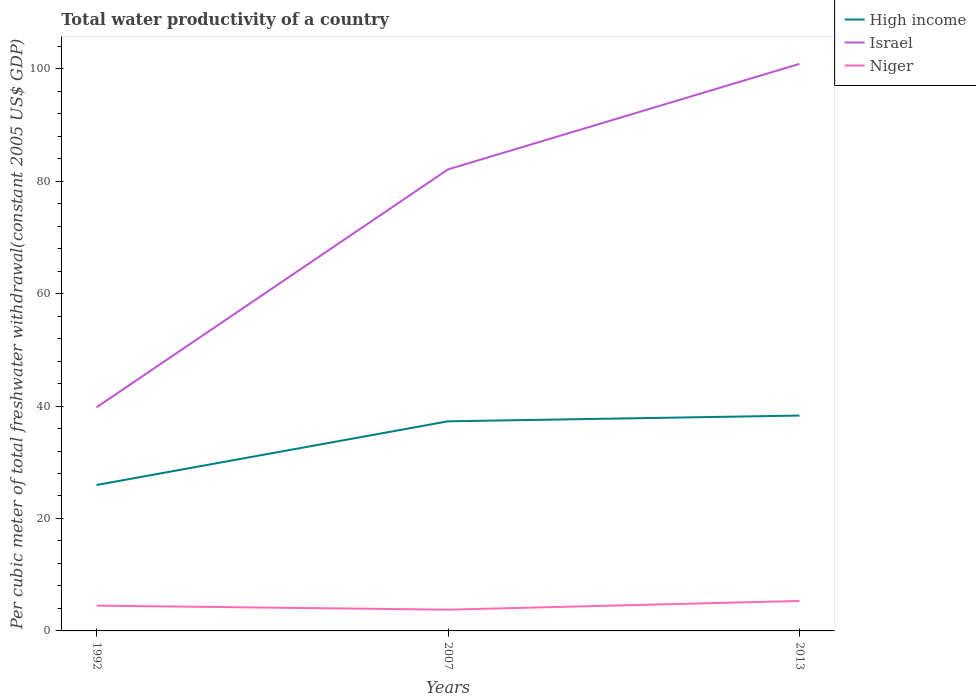Is the number of lines equal to the number of legend labels?
Make the answer very short. Yes. Across all years, what is the maximum total water productivity in Niger?
Ensure brevity in your answer.  3.78. What is the total total water productivity in Niger in the graph?
Make the answer very short. 0.72. What is the difference between the highest and the second highest total water productivity in Israel?
Provide a succinct answer. 61.08. Is the total water productivity in High income strictly greater than the total water productivity in Niger over the years?
Offer a terse response. No. How many lines are there?
Provide a short and direct response. 3. What is the difference between two consecutive major ticks on the Y-axis?
Provide a short and direct response. 20. Are the values on the major ticks of Y-axis written in scientific E-notation?
Offer a terse response. No. Does the graph contain any zero values?
Make the answer very short. No. Does the graph contain grids?
Your answer should be compact. No. Where does the legend appear in the graph?
Your answer should be compact. Top right. How many legend labels are there?
Ensure brevity in your answer.  3. What is the title of the graph?
Keep it short and to the point. Total water productivity of a country. Does "Burundi" appear as one of the legend labels in the graph?
Provide a short and direct response. No. What is the label or title of the Y-axis?
Your answer should be compact. Per cubic meter of total freshwater withdrawal(constant 2005 US$ GDP). What is the Per cubic meter of total freshwater withdrawal(constant 2005 US$ GDP) of High income in 1992?
Make the answer very short. 25.95. What is the Per cubic meter of total freshwater withdrawal(constant 2005 US$ GDP) of Israel in 1992?
Offer a terse response. 39.77. What is the Per cubic meter of total freshwater withdrawal(constant 2005 US$ GDP) in Niger in 1992?
Keep it short and to the point. 4.5. What is the Per cubic meter of total freshwater withdrawal(constant 2005 US$ GDP) of High income in 2007?
Make the answer very short. 37.28. What is the Per cubic meter of total freshwater withdrawal(constant 2005 US$ GDP) in Israel in 2007?
Ensure brevity in your answer.  82.09. What is the Per cubic meter of total freshwater withdrawal(constant 2005 US$ GDP) in Niger in 2007?
Your answer should be compact. 3.78. What is the Per cubic meter of total freshwater withdrawal(constant 2005 US$ GDP) of High income in 2013?
Give a very brief answer. 38.3. What is the Per cubic meter of total freshwater withdrawal(constant 2005 US$ GDP) of Israel in 2013?
Provide a succinct answer. 100.85. What is the Per cubic meter of total freshwater withdrawal(constant 2005 US$ GDP) in Niger in 2013?
Keep it short and to the point. 5.33. Across all years, what is the maximum Per cubic meter of total freshwater withdrawal(constant 2005 US$ GDP) of High income?
Keep it short and to the point. 38.3. Across all years, what is the maximum Per cubic meter of total freshwater withdrawal(constant 2005 US$ GDP) of Israel?
Your response must be concise. 100.85. Across all years, what is the maximum Per cubic meter of total freshwater withdrawal(constant 2005 US$ GDP) in Niger?
Your response must be concise. 5.33. Across all years, what is the minimum Per cubic meter of total freshwater withdrawal(constant 2005 US$ GDP) of High income?
Your answer should be compact. 25.95. Across all years, what is the minimum Per cubic meter of total freshwater withdrawal(constant 2005 US$ GDP) of Israel?
Make the answer very short. 39.77. Across all years, what is the minimum Per cubic meter of total freshwater withdrawal(constant 2005 US$ GDP) of Niger?
Your answer should be very brief. 3.78. What is the total Per cubic meter of total freshwater withdrawal(constant 2005 US$ GDP) of High income in the graph?
Offer a very short reply. 101.54. What is the total Per cubic meter of total freshwater withdrawal(constant 2005 US$ GDP) in Israel in the graph?
Your answer should be compact. 222.71. What is the total Per cubic meter of total freshwater withdrawal(constant 2005 US$ GDP) in Niger in the graph?
Offer a terse response. 13.61. What is the difference between the Per cubic meter of total freshwater withdrawal(constant 2005 US$ GDP) of High income in 1992 and that in 2007?
Offer a very short reply. -11.33. What is the difference between the Per cubic meter of total freshwater withdrawal(constant 2005 US$ GDP) of Israel in 1992 and that in 2007?
Ensure brevity in your answer.  -42.31. What is the difference between the Per cubic meter of total freshwater withdrawal(constant 2005 US$ GDP) in Niger in 1992 and that in 2007?
Provide a short and direct response. 0.72. What is the difference between the Per cubic meter of total freshwater withdrawal(constant 2005 US$ GDP) of High income in 1992 and that in 2013?
Offer a very short reply. -12.35. What is the difference between the Per cubic meter of total freshwater withdrawal(constant 2005 US$ GDP) in Israel in 1992 and that in 2013?
Provide a succinct answer. -61.08. What is the difference between the Per cubic meter of total freshwater withdrawal(constant 2005 US$ GDP) in Niger in 1992 and that in 2013?
Offer a terse response. -0.83. What is the difference between the Per cubic meter of total freshwater withdrawal(constant 2005 US$ GDP) in High income in 2007 and that in 2013?
Make the answer very short. -1.02. What is the difference between the Per cubic meter of total freshwater withdrawal(constant 2005 US$ GDP) in Israel in 2007 and that in 2013?
Give a very brief answer. -18.77. What is the difference between the Per cubic meter of total freshwater withdrawal(constant 2005 US$ GDP) of Niger in 2007 and that in 2013?
Ensure brevity in your answer.  -1.55. What is the difference between the Per cubic meter of total freshwater withdrawal(constant 2005 US$ GDP) in High income in 1992 and the Per cubic meter of total freshwater withdrawal(constant 2005 US$ GDP) in Israel in 2007?
Your answer should be very brief. -56.13. What is the difference between the Per cubic meter of total freshwater withdrawal(constant 2005 US$ GDP) of High income in 1992 and the Per cubic meter of total freshwater withdrawal(constant 2005 US$ GDP) of Niger in 2007?
Ensure brevity in your answer.  22.18. What is the difference between the Per cubic meter of total freshwater withdrawal(constant 2005 US$ GDP) of Israel in 1992 and the Per cubic meter of total freshwater withdrawal(constant 2005 US$ GDP) of Niger in 2007?
Give a very brief answer. 35.99. What is the difference between the Per cubic meter of total freshwater withdrawal(constant 2005 US$ GDP) in High income in 1992 and the Per cubic meter of total freshwater withdrawal(constant 2005 US$ GDP) in Israel in 2013?
Provide a short and direct response. -74.9. What is the difference between the Per cubic meter of total freshwater withdrawal(constant 2005 US$ GDP) of High income in 1992 and the Per cubic meter of total freshwater withdrawal(constant 2005 US$ GDP) of Niger in 2013?
Provide a short and direct response. 20.62. What is the difference between the Per cubic meter of total freshwater withdrawal(constant 2005 US$ GDP) of Israel in 1992 and the Per cubic meter of total freshwater withdrawal(constant 2005 US$ GDP) of Niger in 2013?
Your answer should be very brief. 34.44. What is the difference between the Per cubic meter of total freshwater withdrawal(constant 2005 US$ GDP) of High income in 2007 and the Per cubic meter of total freshwater withdrawal(constant 2005 US$ GDP) of Israel in 2013?
Provide a short and direct response. -63.57. What is the difference between the Per cubic meter of total freshwater withdrawal(constant 2005 US$ GDP) of High income in 2007 and the Per cubic meter of total freshwater withdrawal(constant 2005 US$ GDP) of Niger in 2013?
Keep it short and to the point. 31.95. What is the difference between the Per cubic meter of total freshwater withdrawal(constant 2005 US$ GDP) in Israel in 2007 and the Per cubic meter of total freshwater withdrawal(constant 2005 US$ GDP) in Niger in 2013?
Give a very brief answer. 76.76. What is the average Per cubic meter of total freshwater withdrawal(constant 2005 US$ GDP) of High income per year?
Provide a succinct answer. 33.85. What is the average Per cubic meter of total freshwater withdrawal(constant 2005 US$ GDP) in Israel per year?
Make the answer very short. 74.24. What is the average Per cubic meter of total freshwater withdrawal(constant 2005 US$ GDP) of Niger per year?
Your answer should be very brief. 4.54. In the year 1992, what is the difference between the Per cubic meter of total freshwater withdrawal(constant 2005 US$ GDP) in High income and Per cubic meter of total freshwater withdrawal(constant 2005 US$ GDP) in Israel?
Your answer should be very brief. -13.82. In the year 1992, what is the difference between the Per cubic meter of total freshwater withdrawal(constant 2005 US$ GDP) of High income and Per cubic meter of total freshwater withdrawal(constant 2005 US$ GDP) of Niger?
Your response must be concise. 21.45. In the year 1992, what is the difference between the Per cubic meter of total freshwater withdrawal(constant 2005 US$ GDP) of Israel and Per cubic meter of total freshwater withdrawal(constant 2005 US$ GDP) of Niger?
Provide a succinct answer. 35.27. In the year 2007, what is the difference between the Per cubic meter of total freshwater withdrawal(constant 2005 US$ GDP) of High income and Per cubic meter of total freshwater withdrawal(constant 2005 US$ GDP) of Israel?
Your response must be concise. -44.81. In the year 2007, what is the difference between the Per cubic meter of total freshwater withdrawal(constant 2005 US$ GDP) in High income and Per cubic meter of total freshwater withdrawal(constant 2005 US$ GDP) in Niger?
Your response must be concise. 33.5. In the year 2007, what is the difference between the Per cubic meter of total freshwater withdrawal(constant 2005 US$ GDP) of Israel and Per cubic meter of total freshwater withdrawal(constant 2005 US$ GDP) of Niger?
Offer a terse response. 78.31. In the year 2013, what is the difference between the Per cubic meter of total freshwater withdrawal(constant 2005 US$ GDP) in High income and Per cubic meter of total freshwater withdrawal(constant 2005 US$ GDP) in Israel?
Make the answer very short. -62.55. In the year 2013, what is the difference between the Per cubic meter of total freshwater withdrawal(constant 2005 US$ GDP) of High income and Per cubic meter of total freshwater withdrawal(constant 2005 US$ GDP) of Niger?
Provide a short and direct response. 32.97. In the year 2013, what is the difference between the Per cubic meter of total freshwater withdrawal(constant 2005 US$ GDP) in Israel and Per cubic meter of total freshwater withdrawal(constant 2005 US$ GDP) in Niger?
Your response must be concise. 95.52. What is the ratio of the Per cubic meter of total freshwater withdrawal(constant 2005 US$ GDP) in High income in 1992 to that in 2007?
Your response must be concise. 0.7. What is the ratio of the Per cubic meter of total freshwater withdrawal(constant 2005 US$ GDP) of Israel in 1992 to that in 2007?
Your answer should be compact. 0.48. What is the ratio of the Per cubic meter of total freshwater withdrawal(constant 2005 US$ GDP) of Niger in 1992 to that in 2007?
Ensure brevity in your answer.  1.19. What is the ratio of the Per cubic meter of total freshwater withdrawal(constant 2005 US$ GDP) in High income in 1992 to that in 2013?
Give a very brief answer. 0.68. What is the ratio of the Per cubic meter of total freshwater withdrawal(constant 2005 US$ GDP) of Israel in 1992 to that in 2013?
Give a very brief answer. 0.39. What is the ratio of the Per cubic meter of total freshwater withdrawal(constant 2005 US$ GDP) in Niger in 1992 to that in 2013?
Offer a terse response. 0.84. What is the ratio of the Per cubic meter of total freshwater withdrawal(constant 2005 US$ GDP) in High income in 2007 to that in 2013?
Your answer should be very brief. 0.97. What is the ratio of the Per cubic meter of total freshwater withdrawal(constant 2005 US$ GDP) in Israel in 2007 to that in 2013?
Your response must be concise. 0.81. What is the ratio of the Per cubic meter of total freshwater withdrawal(constant 2005 US$ GDP) in Niger in 2007 to that in 2013?
Offer a terse response. 0.71. What is the difference between the highest and the second highest Per cubic meter of total freshwater withdrawal(constant 2005 US$ GDP) in High income?
Offer a terse response. 1.02. What is the difference between the highest and the second highest Per cubic meter of total freshwater withdrawal(constant 2005 US$ GDP) of Israel?
Make the answer very short. 18.77. What is the difference between the highest and the second highest Per cubic meter of total freshwater withdrawal(constant 2005 US$ GDP) of Niger?
Your response must be concise. 0.83. What is the difference between the highest and the lowest Per cubic meter of total freshwater withdrawal(constant 2005 US$ GDP) in High income?
Make the answer very short. 12.35. What is the difference between the highest and the lowest Per cubic meter of total freshwater withdrawal(constant 2005 US$ GDP) in Israel?
Your response must be concise. 61.08. What is the difference between the highest and the lowest Per cubic meter of total freshwater withdrawal(constant 2005 US$ GDP) of Niger?
Provide a short and direct response. 1.55. 